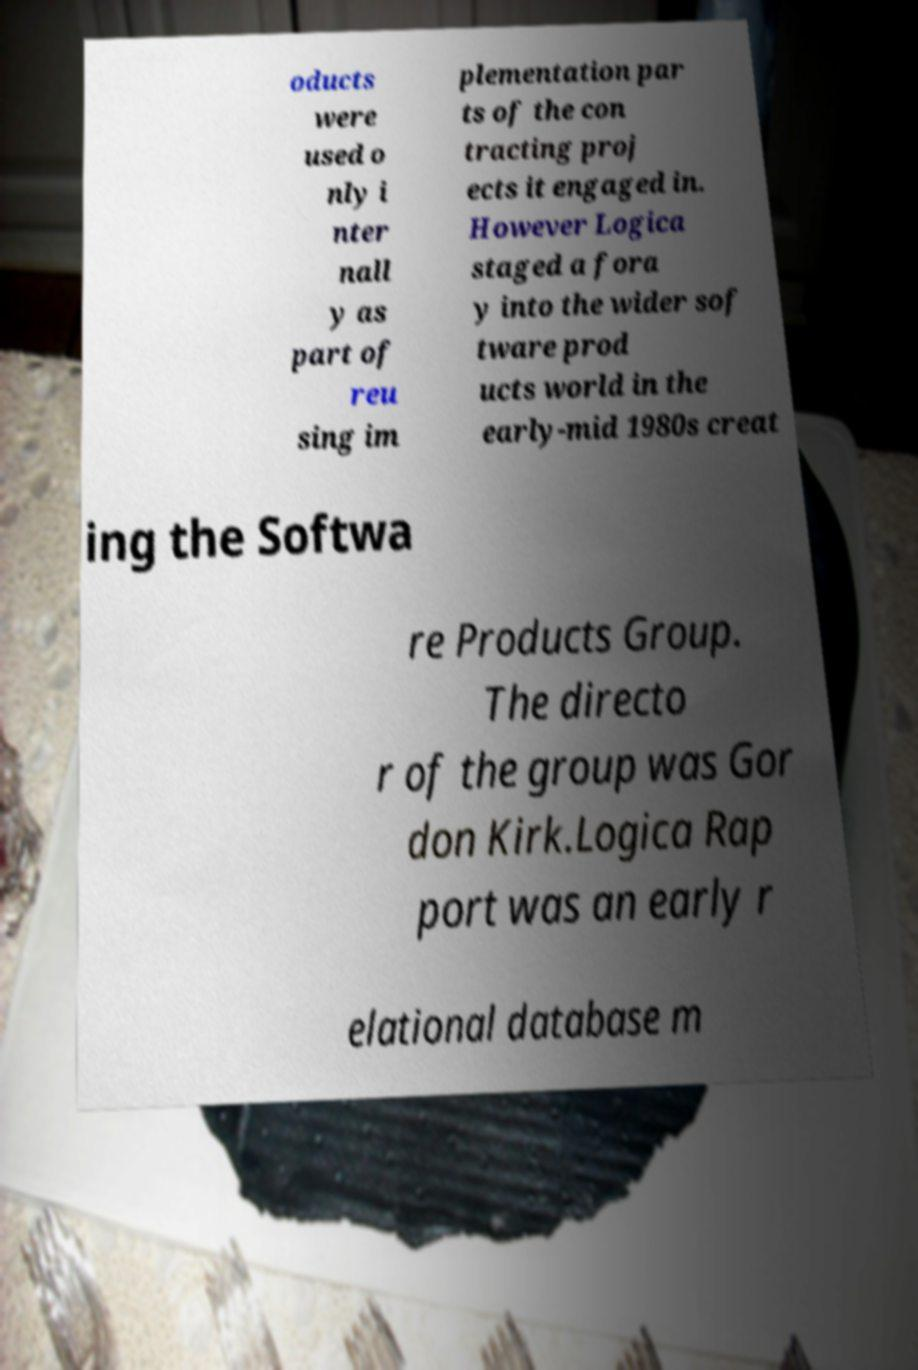Could you extract and type out the text from this image? oducts were used o nly i nter nall y as part of reu sing im plementation par ts of the con tracting proj ects it engaged in. However Logica staged a fora y into the wider sof tware prod ucts world in the early-mid 1980s creat ing the Softwa re Products Group. The directo r of the group was Gor don Kirk.Logica Rap port was an early r elational database m 